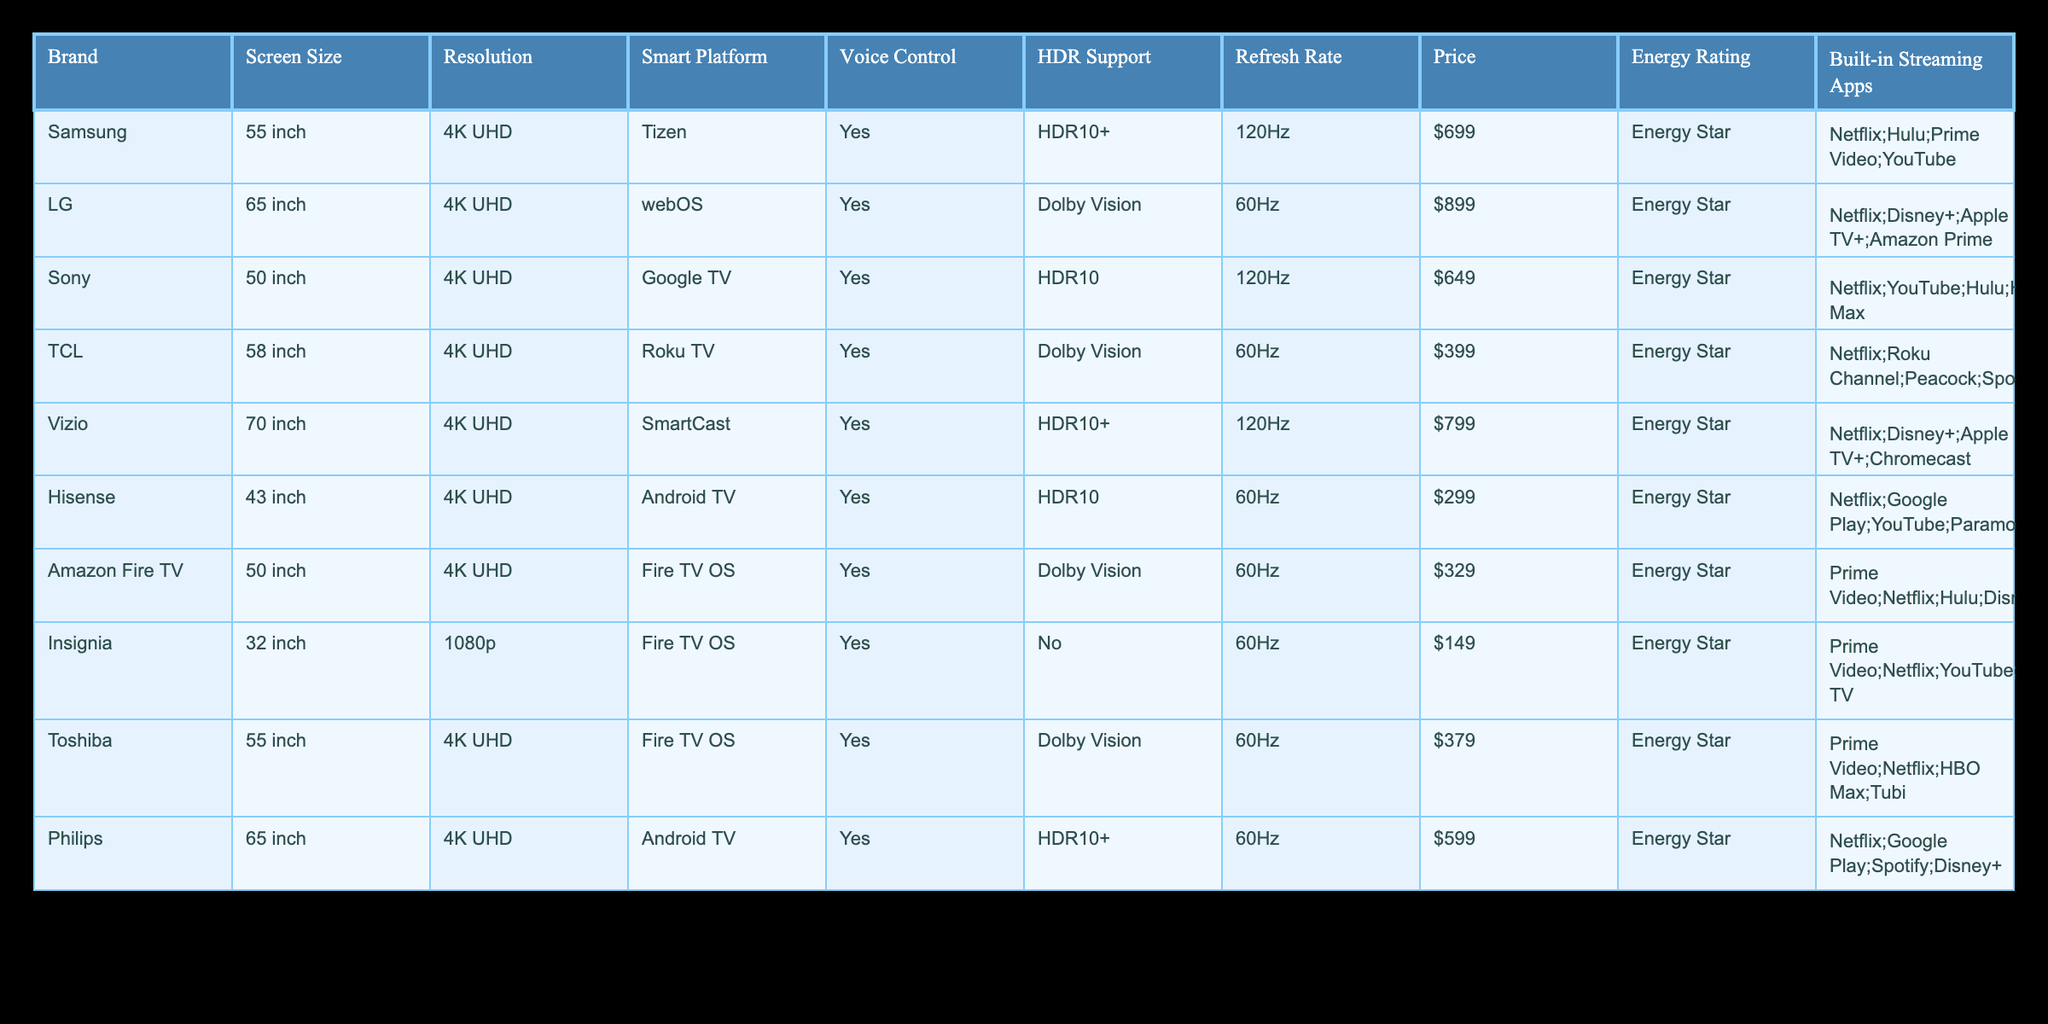What is the price of the LG TV? The LG TV is listed at $899 in the table. It's found in the row corresponding to LG under the Price column.
Answer: $899 Which smart platform does the Sony TV use? The Sony TV operates on the Google TV smart platform. This information can be directly retrieved from the corresponding row of the table under the Smart Platform column.
Answer: Google TV How many TVs support HDR10+? In the table, three TVs support HDR10+, specifically Samsung, Vizio, and Philips. We can count the rows with HDR10+ in the HDR Support column to arrive at this total.
Answer: 3 What is the average price of all TVs listed? To find the average price, we need to sum up all the prices ($699 + $899 + $649 + $399 + $799 + $299 + $329 + $149 + $379 + $599) which equals $4990, then divide by the number of TVs (10). Thus, the average price is $4990/10 = $499.
Answer: $499 Is the TCL TV more expensive than the Hisense TV? The TCL TV is priced at $399, while the Hisense TV is priced at $299. Comparing the two prices shows that $399 is greater than $299. Hence, the TCL TV is indeed more expensive.
Answer: Yes Which TV has the highest refresh rate and what is it? By reviewing the Refresh Rate column, we find that both the Samsung and Vizio TVs have the highest refresh rate of 120Hz. We determine this by comparing all values in that column.
Answer: 120Hz Are there any TVs that do not support HDR? By checking the HDR Support column, we see that the Insignia TV does not support HDR, as it lists "No" under that category. Therefore, there is at least one TV that does not support HDR.
Answer: Yes What is the combined screen size of the largest two TVs? The two largest TVs are the Vizio with a screen size of 70 inches and the LG with a screen size of 65 inches. Summing those gives us 70 + 65 = 135 inches. Therefore, the combined screen size is 135 inches.
Answer: 135 inches How many TVs have a price under $400? We look at the Price column and find that there are three TVs priced under $400: Hisense ($299), Amazon Fire TV ($329), and TCL ($399). Counting these gives us a total of three TVs in that price range.
Answer: 3 